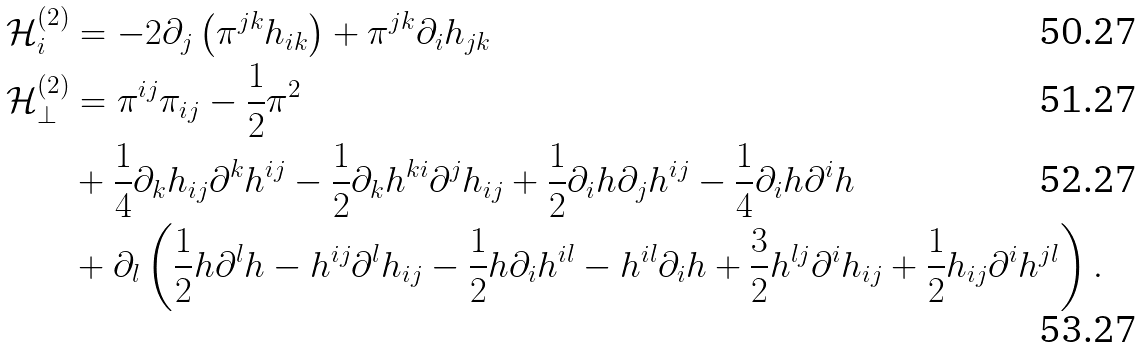Convert formula to latex. <formula><loc_0><loc_0><loc_500><loc_500>\mathcal { H } ^ { ( 2 ) } _ { i } & = - 2 \partial _ { j } \left ( \pi ^ { j k } h _ { i k } \right ) + \pi ^ { j k } \partial _ { i } h _ { j k } \\ \mathcal { H } ^ { ( 2 ) } _ { \perp } & = \pi ^ { i j } \pi _ { i j } - \frac { 1 } { 2 } \pi ^ { 2 } \\ & + \frac { 1 } { 4 } \partial _ { k } h _ { i j } \partial ^ { k } h ^ { i j } - \frac { 1 } { 2 } \partial _ { k } h ^ { k i } \partial ^ { j } h _ { i j } + \frac { 1 } { 2 } \partial _ { i } h \partial _ { j } h ^ { i j } - \frac { 1 } { 4 } \partial _ { i } h \partial ^ { i } h \\ & + \partial _ { l } \left ( \frac { 1 } { 2 } h \partial ^ { l } h - h ^ { i j } \partial ^ { l } h _ { i j } - \frac { 1 } { 2 } h \partial _ { i } h ^ { i l } - h ^ { i l } \partial _ { i } h + \frac { 3 } { 2 } h ^ { l j } \partial ^ { i } h _ { i j } + \frac { 1 } { 2 } h _ { i j } \partial ^ { i } h ^ { j l } \right ) .</formula> 